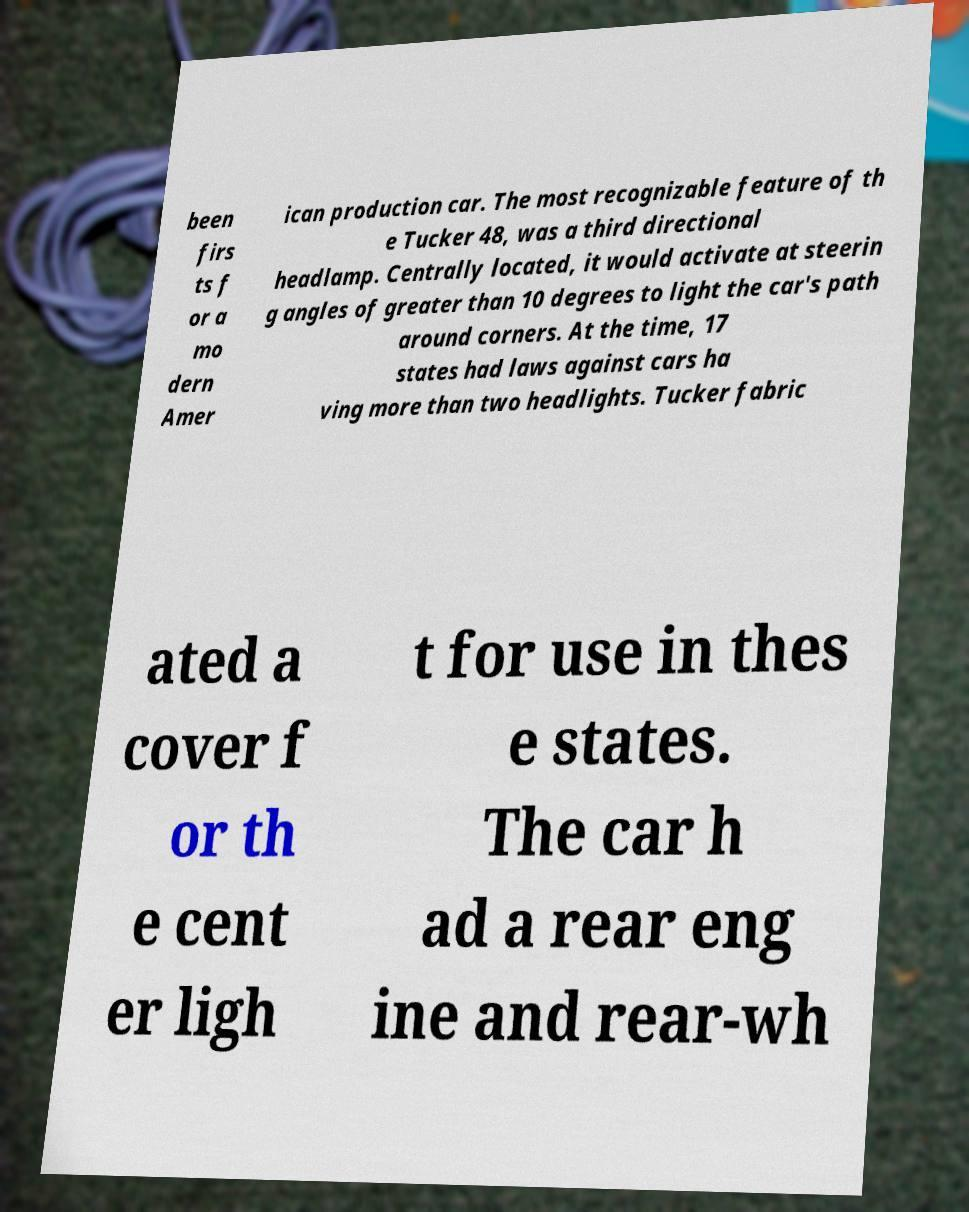Please read and relay the text visible in this image. What does it say? been firs ts f or a mo dern Amer ican production car. The most recognizable feature of th e Tucker 48, was a third directional headlamp. Centrally located, it would activate at steerin g angles of greater than 10 degrees to light the car's path around corners. At the time, 17 states had laws against cars ha ving more than two headlights. Tucker fabric ated a cover f or th e cent er ligh t for use in thes e states. The car h ad a rear eng ine and rear-wh 